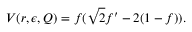<formula> <loc_0><loc_0><loc_500><loc_500>V ( r , \epsilon , Q ) = f ( \sqrt { 2 } f ^ { \prime } - 2 ( 1 - f ) ) .</formula> 